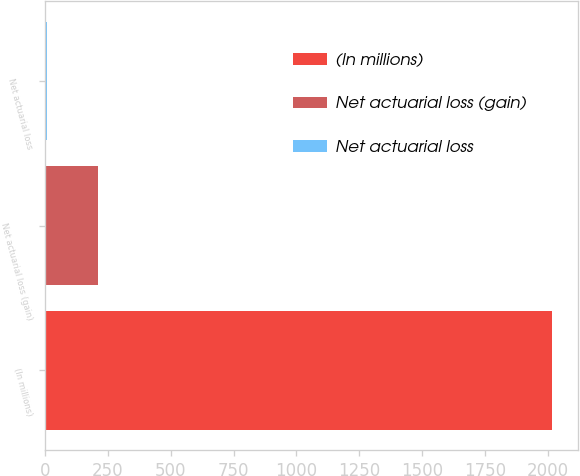Convert chart. <chart><loc_0><loc_0><loc_500><loc_500><bar_chart><fcel>(In millions)<fcel>Net actuarial loss (gain)<fcel>Net actuarial loss<nl><fcel>2018<fcel>209<fcel>8<nl></chart> 